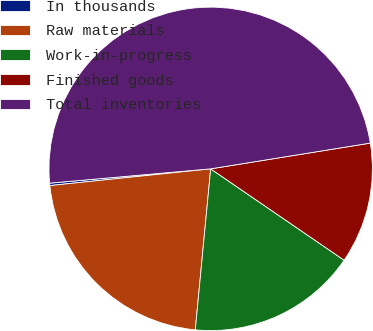Convert chart to OTSL. <chart><loc_0><loc_0><loc_500><loc_500><pie_chart><fcel>In thousands<fcel>Raw materials<fcel>Work-in-progress<fcel>Finished goods<fcel>Total inventories<nl><fcel>0.24%<fcel>21.83%<fcel>16.96%<fcel>12.1%<fcel>48.86%<nl></chart> 